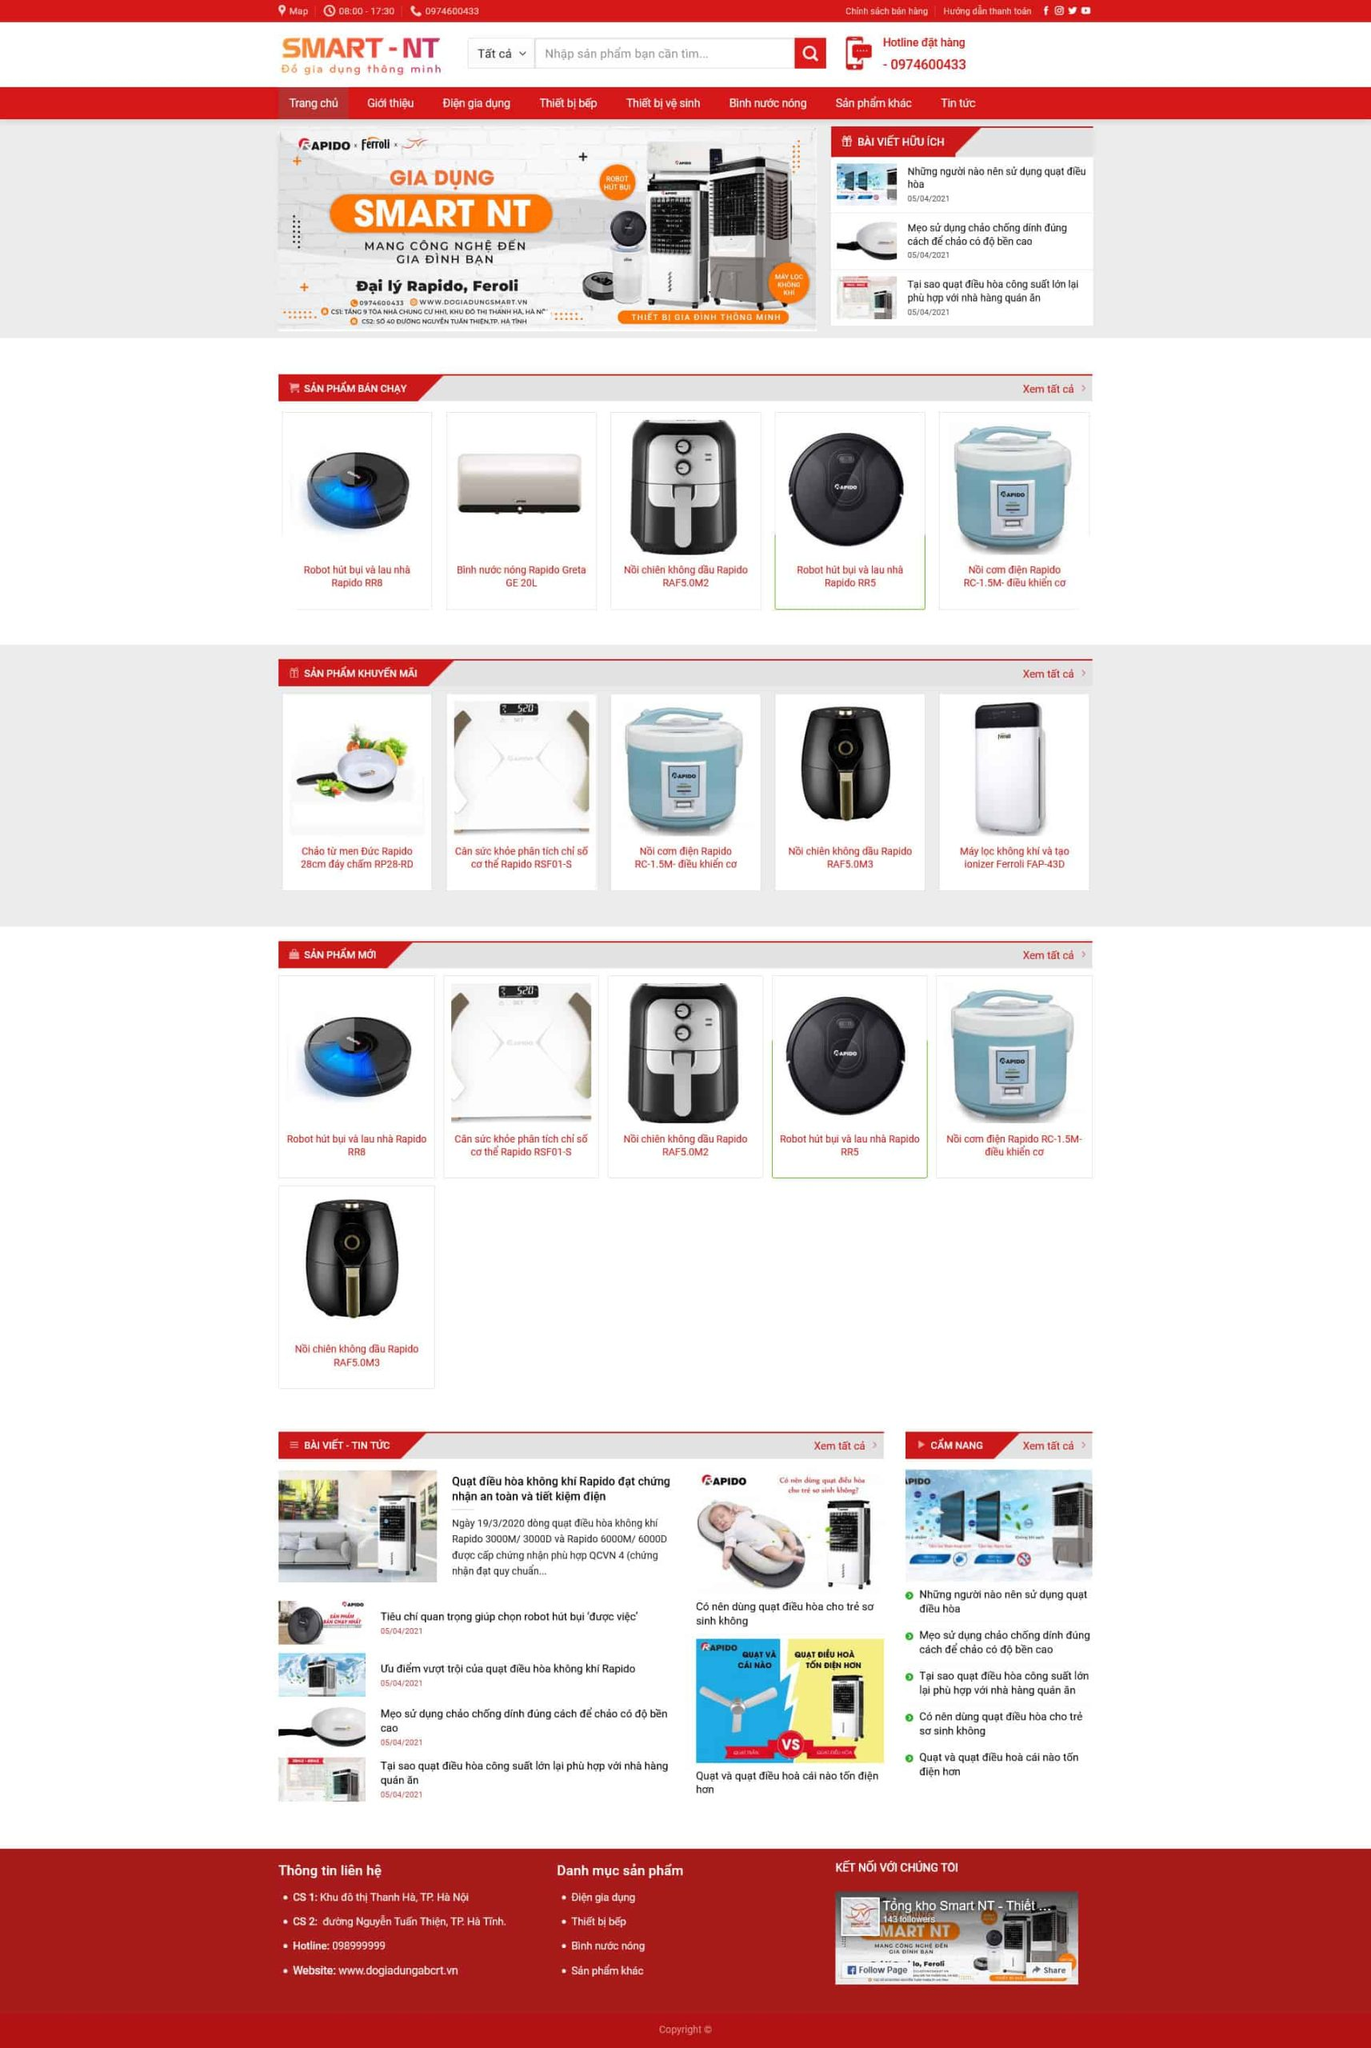Viết một bài viết giới thiệu giao diện website này của DPS MEDIA bao gồm ngành nghề, kiểu dáng, màu sắc, tính năng, bố cục,...Nhưng không nhắc lại liên kết hình ảnh trong bài viết.
 **Giới thiệu giao diện website của DPS MEDIA**

Website của DPS MEDIA chuyên về các sản phẩm gia dụng thông minh, tạo nên một trải nghiệm mua sắm trực tuyến tiện lợi và hiện đại cho người dùng. Ngành nghề kinh doanh chính của website là các thiết bị gia dụng, bao gồm robot hút bụi, nồi cơm điện, máy lọc không khí và nhiều sản phẩm khác.

**Kiểu dáng và màu sắc**
Giao diện website được thiết kế với phong cách hiện đại, sử dụng màu sắc chủ đạo là đỏ và trắng. Màu đỏ tạo nên điểm nhấn nổi bật và thu hút, đồng thời cũng mang lại cảm giác ấm áp, gần gũi. Màu trắng giúp bố cục trang web trở nên sáng sủa và dễ nhìn, tạo cảm giác thoải mái cho người dùng khi duyệt web.

**Tính năng**
Trang web tích hợp nhiều tính năng tiện ích, hỗ trợ người dùng tìm kiếm và mua sắm một cách dễ dàng:
- Thanh tìm kiếm nằm ở vị trí trung tâm, giúp người dùng nhanh chóng tìm thấy sản phẩm mong muốn.
- Danh mục sản phẩm được phân chia rõ ràng thành nhiều nhóm như đồ gia dụng, thiết bị bếp, thiết bị vệ sinh và bình nước nóng.
- Các chức năng như giỏ hàng, hỗ trợ trực tuyến và hướng dẫn sử dụng được bố trí một cách hợp lý để người dùng tiện theo dõi và sử dụng.

**Bố cục**
Bố cục của website được sắp xếp một cách khoa học và hợp lý:
- Phần đầu trang là logo, thanh tìm kiếm và giỏ hàng, giúp người dùng nhanh chóng thao tác các chức năng cần thiết.
- Phần giữa trang là các danh mục sản phẩm nổi bật như "Sản phẩm bán chạy", "Sản phẩm khuyến mãi" và "Sản phẩm mới". Mỗi mục đều hiển thị hình ảnh sản phẩm kèm tên và giá, giúp người dùng dễ dàng so sánh và lựa chọn.
- Phần cuối trang cung cấp thông tin liên hệ, danh mục sản phẩm chi tiết và các bài viết tin tức, giúp người dùng nắm bắt thông tin mới nhất về các sản phẩm và chương trình khuyến mãi.

Tổng thể, giao diện website của DPS MEDIA được thiết kế với sự chú trọng đến trải nghiệm người dùng, từ màu sắc, kiểu dáng đến tính năng và bố cục, mang lại sự tiện lợi và thoải mái khi mua sắm trực tuyến. 